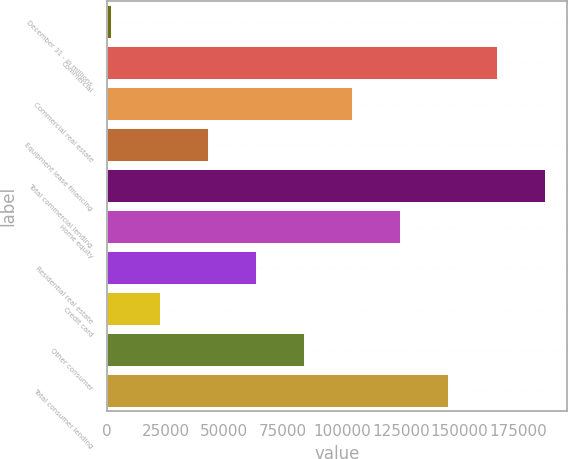<chart> <loc_0><loc_0><loc_500><loc_500><bar_chart><fcel>December 31 - in millions<fcel>Commercial<fcel>Commercial real estate<fcel>Equipment lease financing<fcel>Total commercial lending<fcel>Home equity<fcel>Residential real estate<fcel>Credit card<fcel>Other consumer<fcel>Total consumer lending<nl><fcel>2015<fcel>165760<fcel>104356<fcel>42951.2<fcel>186228<fcel>124824<fcel>63419.3<fcel>22483.1<fcel>83887.4<fcel>145292<nl></chart> 